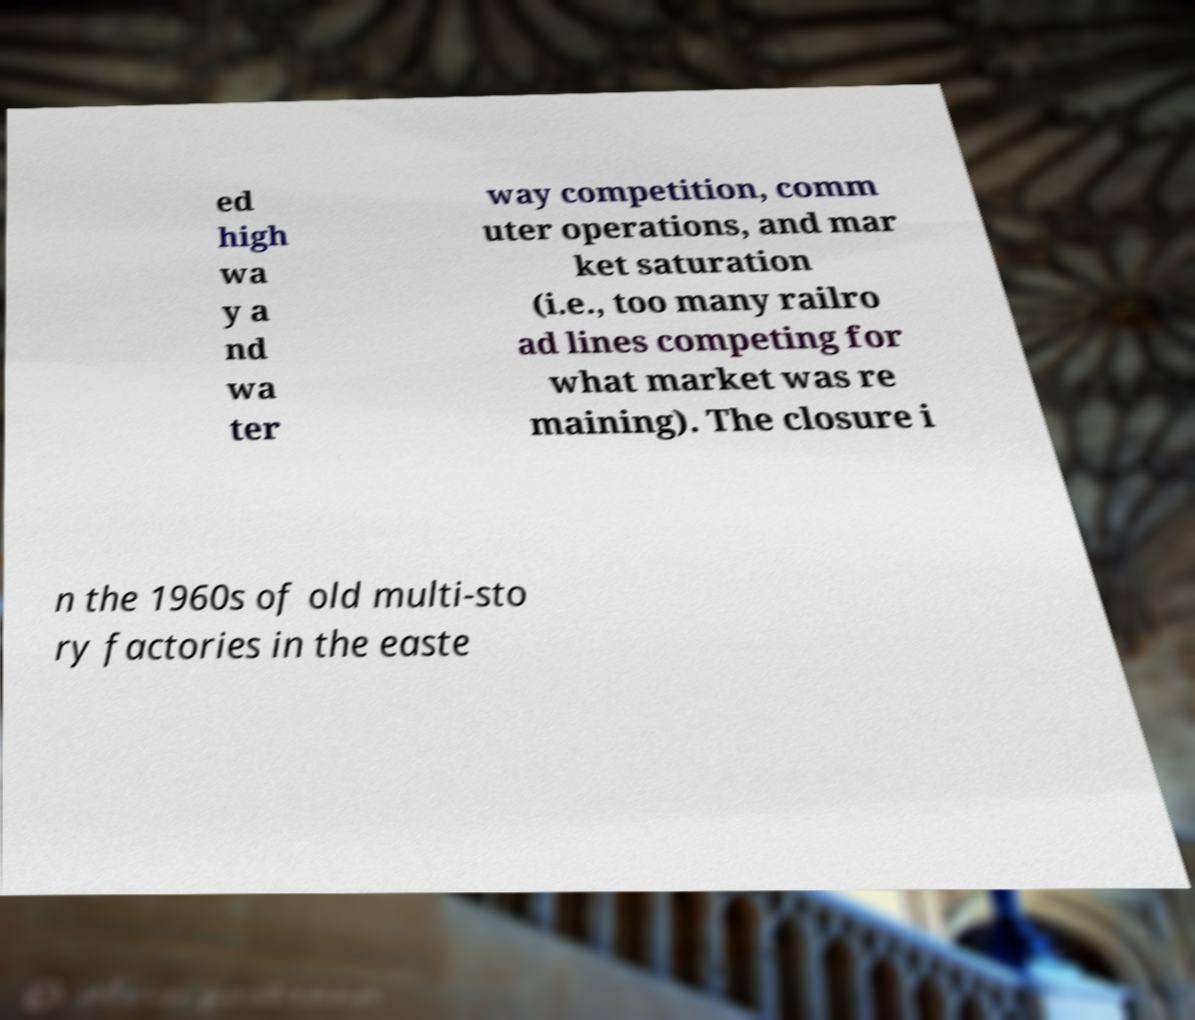For documentation purposes, I need the text within this image transcribed. Could you provide that? ed high wa y a nd wa ter way competition, comm uter operations, and mar ket saturation (i.e., too many railro ad lines competing for what market was re maining). The closure i n the 1960s of old multi-sto ry factories in the easte 